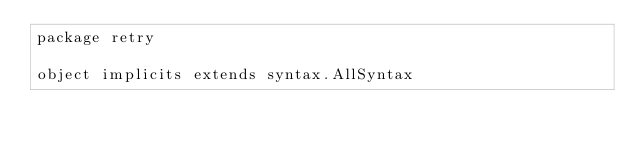Convert code to text. <code><loc_0><loc_0><loc_500><loc_500><_Scala_>package retry

object implicits extends syntax.AllSyntax
</code> 